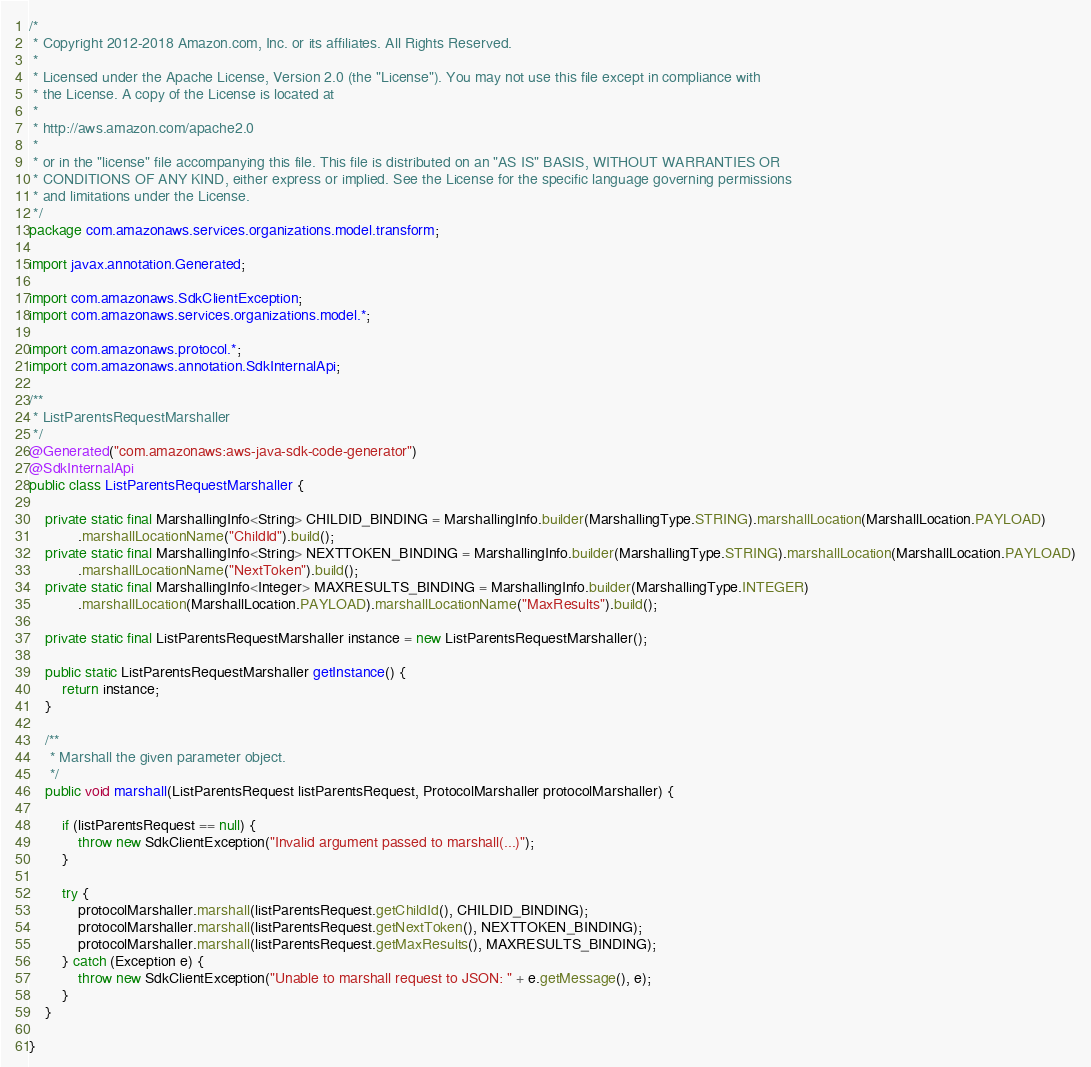<code> <loc_0><loc_0><loc_500><loc_500><_Java_>/*
 * Copyright 2012-2018 Amazon.com, Inc. or its affiliates. All Rights Reserved.
 * 
 * Licensed under the Apache License, Version 2.0 (the "License"). You may not use this file except in compliance with
 * the License. A copy of the License is located at
 * 
 * http://aws.amazon.com/apache2.0
 * 
 * or in the "license" file accompanying this file. This file is distributed on an "AS IS" BASIS, WITHOUT WARRANTIES OR
 * CONDITIONS OF ANY KIND, either express or implied. See the License for the specific language governing permissions
 * and limitations under the License.
 */
package com.amazonaws.services.organizations.model.transform;

import javax.annotation.Generated;

import com.amazonaws.SdkClientException;
import com.amazonaws.services.organizations.model.*;

import com.amazonaws.protocol.*;
import com.amazonaws.annotation.SdkInternalApi;

/**
 * ListParentsRequestMarshaller
 */
@Generated("com.amazonaws:aws-java-sdk-code-generator")
@SdkInternalApi
public class ListParentsRequestMarshaller {

    private static final MarshallingInfo<String> CHILDID_BINDING = MarshallingInfo.builder(MarshallingType.STRING).marshallLocation(MarshallLocation.PAYLOAD)
            .marshallLocationName("ChildId").build();
    private static final MarshallingInfo<String> NEXTTOKEN_BINDING = MarshallingInfo.builder(MarshallingType.STRING).marshallLocation(MarshallLocation.PAYLOAD)
            .marshallLocationName("NextToken").build();
    private static final MarshallingInfo<Integer> MAXRESULTS_BINDING = MarshallingInfo.builder(MarshallingType.INTEGER)
            .marshallLocation(MarshallLocation.PAYLOAD).marshallLocationName("MaxResults").build();

    private static final ListParentsRequestMarshaller instance = new ListParentsRequestMarshaller();

    public static ListParentsRequestMarshaller getInstance() {
        return instance;
    }

    /**
     * Marshall the given parameter object.
     */
    public void marshall(ListParentsRequest listParentsRequest, ProtocolMarshaller protocolMarshaller) {

        if (listParentsRequest == null) {
            throw new SdkClientException("Invalid argument passed to marshall(...)");
        }

        try {
            protocolMarshaller.marshall(listParentsRequest.getChildId(), CHILDID_BINDING);
            protocolMarshaller.marshall(listParentsRequest.getNextToken(), NEXTTOKEN_BINDING);
            protocolMarshaller.marshall(listParentsRequest.getMaxResults(), MAXRESULTS_BINDING);
        } catch (Exception e) {
            throw new SdkClientException("Unable to marshall request to JSON: " + e.getMessage(), e);
        }
    }

}
</code> 